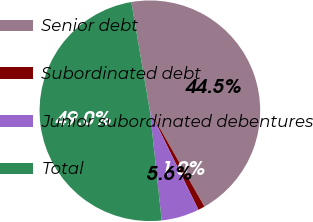Convert chart to OTSL. <chart><loc_0><loc_0><loc_500><loc_500><pie_chart><fcel>Senior debt<fcel>Subordinated debt<fcel>Junior subordinated debentures<fcel>Total<nl><fcel>44.45%<fcel>0.98%<fcel>5.55%<fcel>49.02%<nl></chart> 